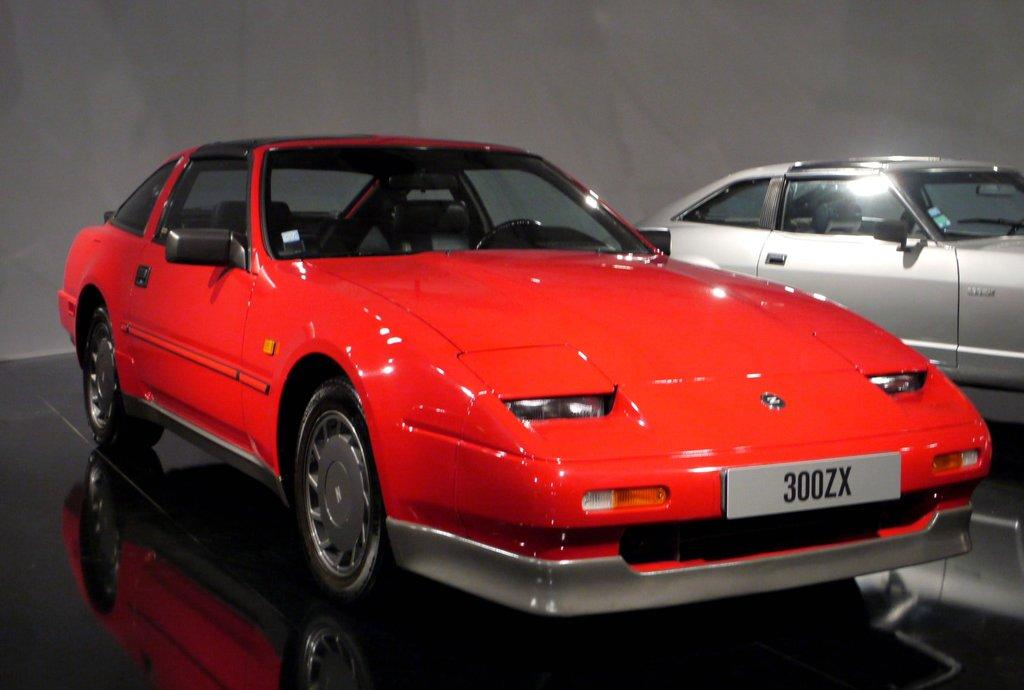What type of vehicles are present in the image? There are cars in the image. What colors can be seen on the cars in the image? The cars are red and grey in color. How many goldfish can be seen swimming in the image? There are no goldfish present in the image. What type of mouth is visible on the cars in the image? Cars do not have mouths, as they are inanimate objects. 